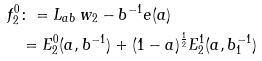<formula> <loc_0><loc_0><loc_500><loc_500>f _ { 2 } ^ { 0 } & \colon = L _ { a b } \, w _ { 2 } - b ^ { - 1 } e ( a ) \\ & = E _ { 2 } ^ { 0 } ( a , b ^ { - 1 } ) + ( 1 - a ) ^ { \frac { 1 } { 2 } } E _ { 2 } ^ { 1 } ( a , b _ { 1 } ^ { - 1 } )</formula> 